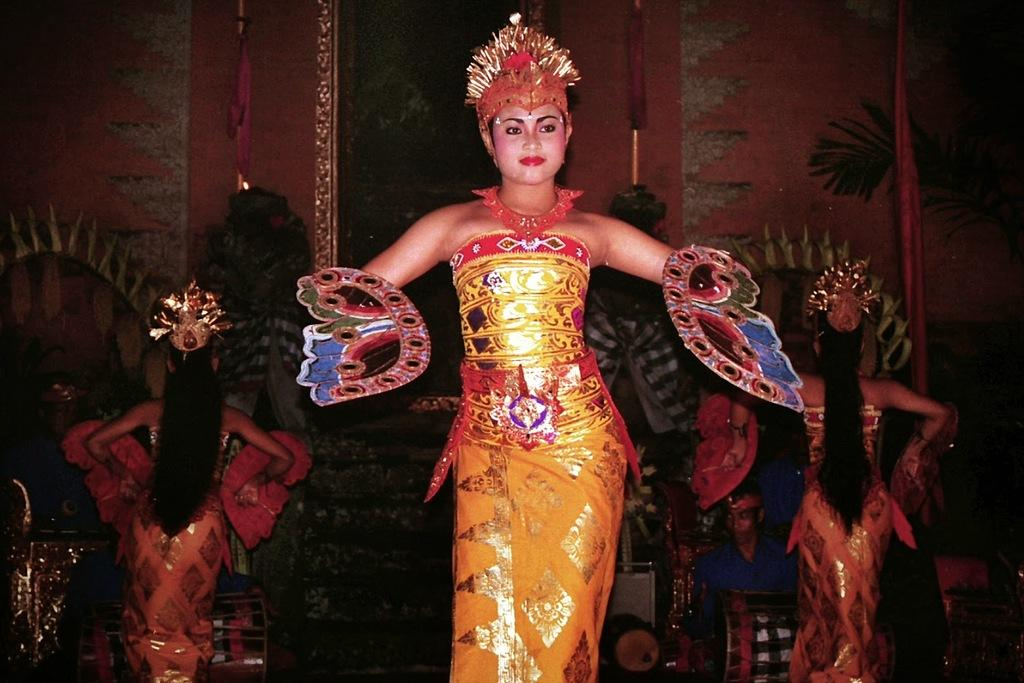What type of people can be seen in the image? There are ladies with costumes in the image. What activity is one person engaged in? There is a person playing a musical instrument in the image. What type of background is visible in the image? There is a wall in the image. What additional elements are present in the image? There are decorations in the image. How many oranges are being held by the ladies in the image? There are no oranges visible in the image. Can you see any veins on the person playing the musical instrument? The image does not provide enough detail to see veins on the person playing the musical instrument. 